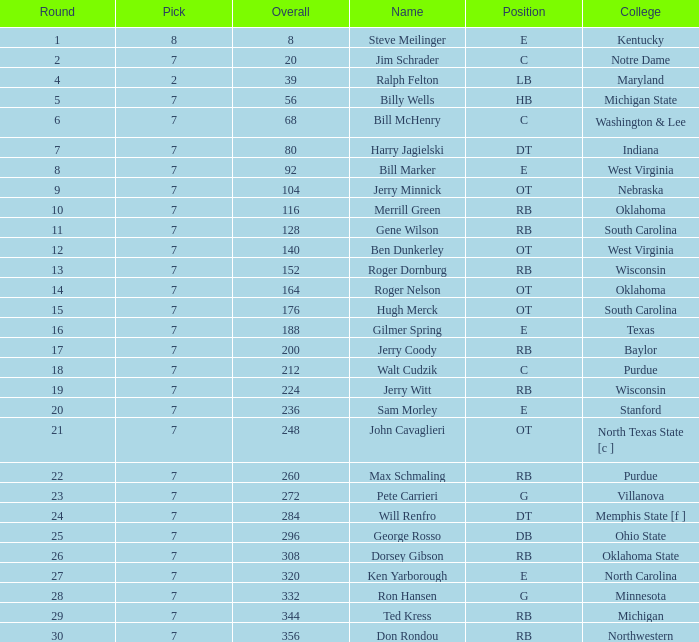At which pick was george rosso drafted when the overall was below 296? 0.0. 